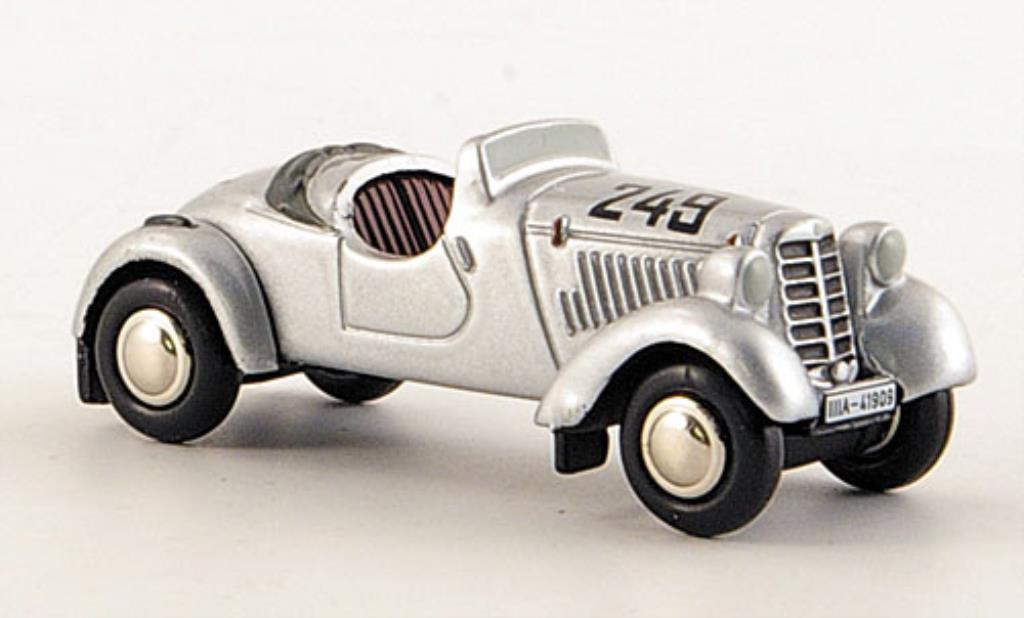Can you tell me about the general design features of this vintage race car? This vintage race car features a sleek, aerodynamic body with exposed wheels and a streamlined form designed to minimize air resistance. The front grille is classic for the era, with vertical slats that facilitate cooling. The car has a single seat, indicating it's built for racing purposes. The simple, rounded lights add a retro aesthetic, and the open cockpit design would have been typical for cars racing in the 1930s, aimed at reducing weight and enhancing speed. 